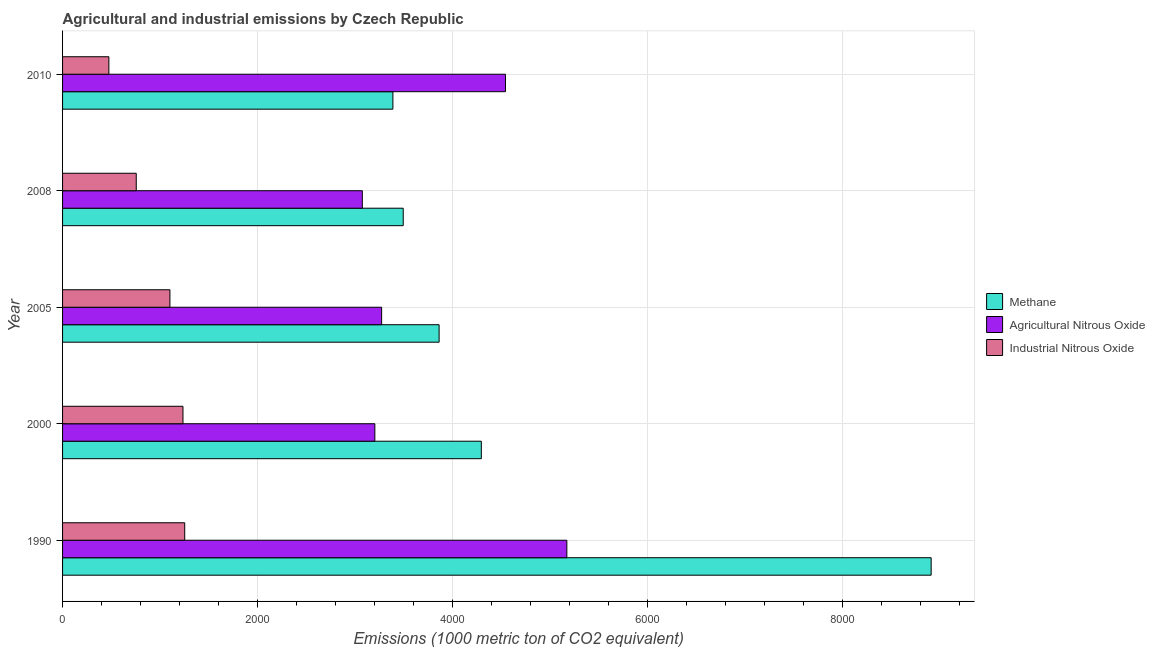How many groups of bars are there?
Your answer should be compact. 5. Are the number of bars per tick equal to the number of legend labels?
Ensure brevity in your answer.  Yes. Are the number of bars on each tick of the Y-axis equal?
Your response must be concise. Yes. How many bars are there on the 3rd tick from the bottom?
Keep it short and to the point. 3. What is the label of the 3rd group of bars from the top?
Your answer should be very brief. 2005. In how many cases, is the number of bars for a given year not equal to the number of legend labels?
Your response must be concise. 0. What is the amount of industrial nitrous oxide emissions in 1990?
Your answer should be compact. 1253.3. Across all years, what is the maximum amount of methane emissions?
Your response must be concise. 8912. Across all years, what is the minimum amount of agricultural nitrous oxide emissions?
Your response must be concise. 3075.6. In which year was the amount of industrial nitrous oxide emissions minimum?
Offer a very short reply. 2010. What is the total amount of methane emissions in the graph?
Your response must be concise. 2.40e+04. What is the difference between the amount of industrial nitrous oxide emissions in 2000 and that in 2005?
Ensure brevity in your answer.  133.9. What is the difference between the amount of industrial nitrous oxide emissions in 2000 and the amount of agricultural nitrous oxide emissions in 2008?
Offer a very short reply. -1840.2. What is the average amount of industrial nitrous oxide emissions per year?
Give a very brief answer. 964.28. In the year 2000, what is the difference between the amount of industrial nitrous oxide emissions and amount of methane emissions?
Provide a succinct answer. -3061.3. What is the ratio of the amount of industrial nitrous oxide emissions in 2005 to that in 2008?
Make the answer very short. 1.46. Is the difference between the amount of agricultural nitrous oxide emissions in 1990 and 2000 greater than the difference between the amount of industrial nitrous oxide emissions in 1990 and 2000?
Your answer should be compact. Yes. What is the difference between the highest and the second highest amount of methane emissions?
Make the answer very short. 4615.3. What is the difference between the highest and the lowest amount of agricultural nitrous oxide emissions?
Your answer should be compact. 2098.5. What does the 2nd bar from the top in 2008 represents?
Offer a very short reply. Agricultural Nitrous Oxide. What does the 1st bar from the bottom in 2000 represents?
Keep it short and to the point. Methane. Is it the case that in every year, the sum of the amount of methane emissions and amount of agricultural nitrous oxide emissions is greater than the amount of industrial nitrous oxide emissions?
Offer a very short reply. Yes. How many bars are there?
Offer a terse response. 15. What is the difference between two consecutive major ticks on the X-axis?
Ensure brevity in your answer.  2000. Are the values on the major ticks of X-axis written in scientific E-notation?
Give a very brief answer. No. Does the graph contain any zero values?
Offer a terse response. No. Does the graph contain grids?
Your response must be concise. Yes. How are the legend labels stacked?
Your answer should be compact. Vertical. What is the title of the graph?
Your response must be concise. Agricultural and industrial emissions by Czech Republic. Does "Taxes" appear as one of the legend labels in the graph?
Give a very brief answer. No. What is the label or title of the X-axis?
Provide a succinct answer. Emissions (1000 metric ton of CO2 equivalent). What is the label or title of the Y-axis?
Ensure brevity in your answer.  Year. What is the Emissions (1000 metric ton of CO2 equivalent) in Methane in 1990?
Your response must be concise. 8912. What is the Emissions (1000 metric ton of CO2 equivalent) in Agricultural Nitrous Oxide in 1990?
Offer a terse response. 5174.1. What is the Emissions (1000 metric ton of CO2 equivalent) in Industrial Nitrous Oxide in 1990?
Ensure brevity in your answer.  1253.3. What is the Emissions (1000 metric ton of CO2 equivalent) in Methane in 2000?
Offer a terse response. 4296.7. What is the Emissions (1000 metric ton of CO2 equivalent) of Agricultural Nitrous Oxide in 2000?
Offer a very short reply. 3204.1. What is the Emissions (1000 metric ton of CO2 equivalent) of Industrial Nitrous Oxide in 2000?
Your answer should be compact. 1235.4. What is the Emissions (1000 metric ton of CO2 equivalent) in Methane in 2005?
Provide a succinct answer. 3863.4. What is the Emissions (1000 metric ton of CO2 equivalent) in Agricultural Nitrous Oxide in 2005?
Make the answer very short. 3273.7. What is the Emissions (1000 metric ton of CO2 equivalent) of Industrial Nitrous Oxide in 2005?
Ensure brevity in your answer.  1101.5. What is the Emissions (1000 metric ton of CO2 equivalent) of Methane in 2008?
Your answer should be compact. 3495.2. What is the Emissions (1000 metric ton of CO2 equivalent) in Agricultural Nitrous Oxide in 2008?
Your response must be concise. 3075.6. What is the Emissions (1000 metric ton of CO2 equivalent) in Industrial Nitrous Oxide in 2008?
Your response must be concise. 756. What is the Emissions (1000 metric ton of CO2 equivalent) in Methane in 2010?
Your answer should be very brief. 3389.3. What is the Emissions (1000 metric ton of CO2 equivalent) of Agricultural Nitrous Oxide in 2010?
Provide a succinct answer. 4544.3. What is the Emissions (1000 metric ton of CO2 equivalent) of Industrial Nitrous Oxide in 2010?
Offer a terse response. 475.2. Across all years, what is the maximum Emissions (1000 metric ton of CO2 equivalent) of Methane?
Offer a very short reply. 8912. Across all years, what is the maximum Emissions (1000 metric ton of CO2 equivalent) of Agricultural Nitrous Oxide?
Ensure brevity in your answer.  5174.1. Across all years, what is the maximum Emissions (1000 metric ton of CO2 equivalent) in Industrial Nitrous Oxide?
Keep it short and to the point. 1253.3. Across all years, what is the minimum Emissions (1000 metric ton of CO2 equivalent) in Methane?
Your answer should be compact. 3389.3. Across all years, what is the minimum Emissions (1000 metric ton of CO2 equivalent) of Agricultural Nitrous Oxide?
Your answer should be very brief. 3075.6. Across all years, what is the minimum Emissions (1000 metric ton of CO2 equivalent) of Industrial Nitrous Oxide?
Your answer should be very brief. 475.2. What is the total Emissions (1000 metric ton of CO2 equivalent) of Methane in the graph?
Provide a succinct answer. 2.40e+04. What is the total Emissions (1000 metric ton of CO2 equivalent) in Agricultural Nitrous Oxide in the graph?
Keep it short and to the point. 1.93e+04. What is the total Emissions (1000 metric ton of CO2 equivalent) of Industrial Nitrous Oxide in the graph?
Ensure brevity in your answer.  4821.4. What is the difference between the Emissions (1000 metric ton of CO2 equivalent) in Methane in 1990 and that in 2000?
Provide a succinct answer. 4615.3. What is the difference between the Emissions (1000 metric ton of CO2 equivalent) in Agricultural Nitrous Oxide in 1990 and that in 2000?
Your answer should be compact. 1970. What is the difference between the Emissions (1000 metric ton of CO2 equivalent) of Industrial Nitrous Oxide in 1990 and that in 2000?
Ensure brevity in your answer.  17.9. What is the difference between the Emissions (1000 metric ton of CO2 equivalent) of Methane in 1990 and that in 2005?
Your response must be concise. 5048.6. What is the difference between the Emissions (1000 metric ton of CO2 equivalent) of Agricultural Nitrous Oxide in 1990 and that in 2005?
Keep it short and to the point. 1900.4. What is the difference between the Emissions (1000 metric ton of CO2 equivalent) of Industrial Nitrous Oxide in 1990 and that in 2005?
Give a very brief answer. 151.8. What is the difference between the Emissions (1000 metric ton of CO2 equivalent) in Methane in 1990 and that in 2008?
Make the answer very short. 5416.8. What is the difference between the Emissions (1000 metric ton of CO2 equivalent) in Agricultural Nitrous Oxide in 1990 and that in 2008?
Your answer should be compact. 2098.5. What is the difference between the Emissions (1000 metric ton of CO2 equivalent) in Industrial Nitrous Oxide in 1990 and that in 2008?
Offer a terse response. 497.3. What is the difference between the Emissions (1000 metric ton of CO2 equivalent) of Methane in 1990 and that in 2010?
Your response must be concise. 5522.7. What is the difference between the Emissions (1000 metric ton of CO2 equivalent) of Agricultural Nitrous Oxide in 1990 and that in 2010?
Make the answer very short. 629.8. What is the difference between the Emissions (1000 metric ton of CO2 equivalent) of Industrial Nitrous Oxide in 1990 and that in 2010?
Your response must be concise. 778.1. What is the difference between the Emissions (1000 metric ton of CO2 equivalent) in Methane in 2000 and that in 2005?
Your answer should be compact. 433.3. What is the difference between the Emissions (1000 metric ton of CO2 equivalent) of Agricultural Nitrous Oxide in 2000 and that in 2005?
Your response must be concise. -69.6. What is the difference between the Emissions (1000 metric ton of CO2 equivalent) in Industrial Nitrous Oxide in 2000 and that in 2005?
Provide a succinct answer. 133.9. What is the difference between the Emissions (1000 metric ton of CO2 equivalent) of Methane in 2000 and that in 2008?
Your response must be concise. 801.5. What is the difference between the Emissions (1000 metric ton of CO2 equivalent) of Agricultural Nitrous Oxide in 2000 and that in 2008?
Offer a terse response. 128.5. What is the difference between the Emissions (1000 metric ton of CO2 equivalent) of Industrial Nitrous Oxide in 2000 and that in 2008?
Give a very brief answer. 479.4. What is the difference between the Emissions (1000 metric ton of CO2 equivalent) in Methane in 2000 and that in 2010?
Ensure brevity in your answer.  907.4. What is the difference between the Emissions (1000 metric ton of CO2 equivalent) of Agricultural Nitrous Oxide in 2000 and that in 2010?
Provide a short and direct response. -1340.2. What is the difference between the Emissions (1000 metric ton of CO2 equivalent) of Industrial Nitrous Oxide in 2000 and that in 2010?
Your answer should be compact. 760.2. What is the difference between the Emissions (1000 metric ton of CO2 equivalent) in Methane in 2005 and that in 2008?
Ensure brevity in your answer.  368.2. What is the difference between the Emissions (1000 metric ton of CO2 equivalent) in Agricultural Nitrous Oxide in 2005 and that in 2008?
Your answer should be compact. 198.1. What is the difference between the Emissions (1000 metric ton of CO2 equivalent) in Industrial Nitrous Oxide in 2005 and that in 2008?
Offer a very short reply. 345.5. What is the difference between the Emissions (1000 metric ton of CO2 equivalent) in Methane in 2005 and that in 2010?
Make the answer very short. 474.1. What is the difference between the Emissions (1000 metric ton of CO2 equivalent) of Agricultural Nitrous Oxide in 2005 and that in 2010?
Ensure brevity in your answer.  -1270.6. What is the difference between the Emissions (1000 metric ton of CO2 equivalent) in Industrial Nitrous Oxide in 2005 and that in 2010?
Ensure brevity in your answer.  626.3. What is the difference between the Emissions (1000 metric ton of CO2 equivalent) of Methane in 2008 and that in 2010?
Make the answer very short. 105.9. What is the difference between the Emissions (1000 metric ton of CO2 equivalent) of Agricultural Nitrous Oxide in 2008 and that in 2010?
Make the answer very short. -1468.7. What is the difference between the Emissions (1000 metric ton of CO2 equivalent) in Industrial Nitrous Oxide in 2008 and that in 2010?
Provide a short and direct response. 280.8. What is the difference between the Emissions (1000 metric ton of CO2 equivalent) in Methane in 1990 and the Emissions (1000 metric ton of CO2 equivalent) in Agricultural Nitrous Oxide in 2000?
Your response must be concise. 5707.9. What is the difference between the Emissions (1000 metric ton of CO2 equivalent) of Methane in 1990 and the Emissions (1000 metric ton of CO2 equivalent) of Industrial Nitrous Oxide in 2000?
Give a very brief answer. 7676.6. What is the difference between the Emissions (1000 metric ton of CO2 equivalent) of Agricultural Nitrous Oxide in 1990 and the Emissions (1000 metric ton of CO2 equivalent) of Industrial Nitrous Oxide in 2000?
Your answer should be very brief. 3938.7. What is the difference between the Emissions (1000 metric ton of CO2 equivalent) in Methane in 1990 and the Emissions (1000 metric ton of CO2 equivalent) in Agricultural Nitrous Oxide in 2005?
Offer a terse response. 5638.3. What is the difference between the Emissions (1000 metric ton of CO2 equivalent) in Methane in 1990 and the Emissions (1000 metric ton of CO2 equivalent) in Industrial Nitrous Oxide in 2005?
Your response must be concise. 7810.5. What is the difference between the Emissions (1000 metric ton of CO2 equivalent) in Agricultural Nitrous Oxide in 1990 and the Emissions (1000 metric ton of CO2 equivalent) in Industrial Nitrous Oxide in 2005?
Your answer should be compact. 4072.6. What is the difference between the Emissions (1000 metric ton of CO2 equivalent) of Methane in 1990 and the Emissions (1000 metric ton of CO2 equivalent) of Agricultural Nitrous Oxide in 2008?
Offer a terse response. 5836.4. What is the difference between the Emissions (1000 metric ton of CO2 equivalent) in Methane in 1990 and the Emissions (1000 metric ton of CO2 equivalent) in Industrial Nitrous Oxide in 2008?
Keep it short and to the point. 8156. What is the difference between the Emissions (1000 metric ton of CO2 equivalent) in Agricultural Nitrous Oxide in 1990 and the Emissions (1000 metric ton of CO2 equivalent) in Industrial Nitrous Oxide in 2008?
Provide a short and direct response. 4418.1. What is the difference between the Emissions (1000 metric ton of CO2 equivalent) in Methane in 1990 and the Emissions (1000 metric ton of CO2 equivalent) in Agricultural Nitrous Oxide in 2010?
Your answer should be very brief. 4367.7. What is the difference between the Emissions (1000 metric ton of CO2 equivalent) in Methane in 1990 and the Emissions (1000 metric ton of CO2 equivalent) in Industrial Nitrous Oxide in 2010?
Keep it short and to the point. 8436.8. What is the difference between the Emissions (1000 metric ton of CO2 equivalent) of Agricultural Nitrous Oxide in 1990 and the Emissions (1000 metric ton of CO2 equivalent) of Industrial Nitrous Oxide in 2010?
Give a very brief answer. 4698.9. What is the difference between the Emissions (1000 metric ton of CO2 equivalent) of Methane in 2000 and the Emissions (1000 metric ton of CO2 equivalent) of Agricultural Nitrous Oxide in 2005?
Keep it short and to the point. 1023. What is the difference between the Emissions (1000 metric ton of CO2 equivalent) of Methane in 2000 and the Emissions (1000 metric ton of CO2 equivalent) of Industrial Nitrous Oxide in 2005?
Give a very brief answer. 3195.2. What is the difference between the Emissions (1000 metric ton of CO2 equivalent) in Agricultural Nitrous Oxide in 2000 and the Emissions (1000 metric ton of CO2 equivalent) in Industrial Nitrous Oxide in 2005?
Your answer should be very brief. 2102.6. What is the difference between the Emissions (1000 metric ton of CO2 equivalent) of Methane in 2000 and the Emissions (1000 metric ton of CO2 equivalent) of Agricultural Nitrous Oxide in 2008?
Offer a very short reply. 1221.1. What is the difference between the Emissions (1000 metric ton of CO2 equivalent) in Methane in 2000 and the Emissions (1000 metric ton of CO2 equivalent) in Industrial Nitrous Oxide in 2008?
Provide a succinct answer. 3540.7. What is the difference between the Emissions (1000 metric ton of CO2 equivalent) in Agricultural Nitrous Oxide in 2000 and the Emissions (1000 metric ton of CO2 equivalent) in Industrial Nitrous Oxide in 2008?
Offer a terse response. 2448.1. What is the difference between the Emissions (1000 metric ton of CO2 equivalent) of Methane in 2000 and the Emissions (1000 metric ton of CO2 equivalent) of Agricultural Nitrous Oxide in 2010?
Ensure brevity in your answer.  -247.6. What is the difference between the Emissions (1000 metric ton of CO2 equivalent) of Methane in 2000 and the Emissions (1000 metric ton of CO2 equivalent) of Industrial Nitrous Oxide in 2010?
Give a very brief answer. 3821.5. What is the difference between the Emissions (1000 metric ton of CO2 equivalent) in Agricultural Nitrous Oxide in 2000 and the Emissions (1000 metric ton of CO2 equivalent) in Industrial Nitrous Oxide in 2010?
Provide a succinct answer. 2728.9. What is the difference between the Emissions (1000 metric ton of CO2 equivalent) of Methane in 2005 and the Emissions (1000 metric ton of CO2 equivalent) of Agricultural Nitrous Oxide in 2008?
Provide a short and direct response. 787.8. What is the difference between the Emissions (1000 metric ton of CO2 equivalent) of Methane in 2005 and the Emissions (1000 metric ton of CO2 equivalent) of Industrial Nitrous Oxide in 2008?
Offer a terse response. 3107.4. What is the difference between the Emissions (1000 metric ton of CO2 equivalent) of Agricultural Nitrous Oxide in 2005 and the Emissions (1000 metric ton of CO2 equivalent) of Industrial Nitrous Oxide in 2008?
Your answer should be very brief. 2517.7. What is the difference between the Emissions (1000 metric ton of CO2 equivalent) of Methane in 2005 and the Emissions (1000 metric ton of CO2 equivalent) of Agricultural Nitrous Oxide in 2010?
Your answer should be very brief. -680.9. What is the difference between the Emissions (1000 metric ton of CO2 equivalent) in Methane in 2005 and the Emissions (1000 metric ton of CO2 equivalent) in Industrial Nitrous Oxide in 2010?
Give a very brief answer. 3388.2. What is the difference between the Emissions (1000 metric ton of CO2 equivalent) in Agricultural Nitrous Oxide in 2005 and the Emissions (1000 metric ton of CO2 equivalent) in Industrial Nitrous Oxide in 2010?
Your answer should be very brief. 2798.5. What is the difference between the Emissions (1000 metric ton of CO2 equivalent) of Methane in 2008 and the Emissions (1000 metric ton of CO2 equivalent) of Agricultural Nitrous Oxide in 2010?
Your answer should be compact. -1049.1. What is the difference between the Emissions (1000 metric ton of CO2 equivalent) in Methane in 2008 and the Emissions (1000 metric ton of CO2 equivalent) in Industrial Nitrous Oxide in 2010?
Provide a short and direct response. 3020. What is the difference between the Emissions (1000 metric ton of CO2 equivalent) of Agricultural Nitrous Oxide in 2008 and the Emissions (1000 metric ton of CO2 equivalent) of Industrial Nitrous Oxide in 2010?
Offer a very short reply. 2600.4. What is the average Emissions (1000 metric ton of CO2 equivalent) of Methane per year?
Keep it short and to the point. 4791.32. What is the average Emissions (1000 metric ton of CO2 equivalent) of Agricultural Nitrous Oxide per year?
Your answer should be compact. 3854.36. What is the average Emissions (1000 metric ton of CO2 equivalent) in Industrial Nitrous Oxide per year?
Ensure brevity in your answer.  964.28. In the year 1990, what is the difference between the Emissions (1000 metric ton of CO2 equivalent) of Methane and Emissions (1000 metric ton of CO2 equivalent) of Agricultural Nitrous Oxide?
Ensure brevity in your answer.  3737.9. In the year 1990, what is the difference between the Emissions (1000 metric ton of CO2 equivalent) in Methane and Emissions (1000 metric ton of CO2 equivalent) in Industrial Nitrous Oxide?
Give a very brief answer. 7658.7. In the year 1990, what is the difference between the Emissions (1000 metric ton of CO2 equivalent) of Agricultural Nitrous Oxide and Emissions (1000 metric ton of CO2 equivalent) of Industrial Nitrous Oxide?
Give a very brief answer. 3920.8. In the year 2000, what is the difference between the Emissions (1000 metric ton of CO2 equivalent) in Methane and Emissions (1000 metric ton of CO2 equivalent) in Agricultural Nitrous Oxide?
Make the answer very short. 1092.6. In the year 2000, what is the difference between the Emissions (1000 metric ton of CO2 equivalent) in Methane and Emissions (1000 metric ton of CO2 equivalent) in Industrial Nitrous Oxide?
Ensure brevity in your answer.  3061.3. In the year 2000, what is the difference between the Emissions (1000 metric ton of CO2 equivalent) in Agricultural Nitrous Oxide and Emissions (1000 metric ton of CO2 equivalent) in Industrial Nitrous Oxide?
Your response must be concise. 1968.7. In the year 2005, what is the difference between the Emissions (1000 metric ton of CO2 equivalent) of Methane and Emissions (1000 metric ton of CO2 equivalent) of Agricultural Nitrous Oxide?
Provide a short and direct response. 589.7. In the year 2005, what is the difference between the Emissions (1000 metric ton of CO2 equivalent) in Methane and Emissions (1000 metric ton of CO2 equivalent) in Industrial Nitrous Oxide?
Keep it short and to the point. 2761.9. In the year 2005, what is the difference between the Emissions (1000 metric ton of CO2 equivalent) of Agricultural Nitrous Oxide and Emissions (1000 metric ton of CO2 equivalent) of Industrial Nitrous Oxide?
Give a very brief answer. 2172.2. In the year 2008, what is the difference between the Emissions (1000 metric ton of CO2 equivalent) in Methane and Emissions (1000 metric ton of CO2 equivalent) in Agricultural Nitrous Oxide?
Your answer should be very brief. 419.6. In the year 2008, what is the difference between the Emissions (1000 metric ton of CO2 equivalent) of Methane and Emissions (1000 metric ton of CO2 equivalent) of Industrial Nitrous Oxide?
Offer a very short reply. 2739.2. In the year 2008, what is the difference between the Emissions (1000 metric ton of CO2 equivalent) in Agricultural Nitrous Oxide and Emissions (1000 metric ton of CO2 equivalent) in Industrial Nitrous Oxide?
Your answer should be compact. 2319.6. In the year 2010, what is the difference between the Emissions (1000 metric ton of CO2 equivalent) in Methane and Emissions (1000 metric ton of CO2 equivalent) in Agricultural Nitrous Oxide?
Your answer should be very brief. -1155. In the year 2010, what is the difference between the Emissions (1000 metric ton of CO2 equivalent) of Methane and Emissions (1000 metric ton of CO2 equivalent) of Industrial Nitrous Oxide?
Make the answer very short. 2914.1. In the year 2010, what is the difference between the Emissions (1000 metric ton of CO2 equivalent) of Agricultural Nitrous Oxide and Emissions (1000 metric ton of CO2 equivalent) of Industrial Nitrous Oxide?
Provide a succinct answer. 4069.1. What is the ratio of the Emissions (1000 metric ton of CO2 equivalent) in Methane in 1990 to that in 2000?
Give a very brief answer. 2.07. What is the ratio of the Emissions (1000 metric ton of CO2 equivalent) of Agricultural Nitrous Oxide in 1990 to that in 2000?
Offer a terse response. 1.61. What is the ratio of the Emissions (1000 metric ton of CO2 equivalent) of Industrial Nitrous Oxide in 1990 to that in 2000?
Make the answer very short. 1.01. What is the ratio of the Emissions (1000 metric ton of CO2 equivalent) of Methane in 1990 to that in 2005?
Your response must be concise. 2.31. What is the ratio of the Emissions (1000 metric ton of CO2 equivalent) of Agricultural Nitrous Oxide in 1990 to that in 2005?
Keep it short and to the point. 1.58. What is the ratio of the Emissions (1000 metric ton of CO2 equivalent) in Industrial Nitrous Oxide in 1990 to that in 2005?
Your answer should be very brief. 1.14. What is the ratio of the Emissions (1000 metric ton of CO2 equivalent) in Methane in 1990 to that in 2008?
Provide a succinct answer. 2.55. What is the ratio of the Emissions (1000 metric ton of CO2 equivalent) of Agricultural Nitrous Oxide in 1990 to that in 2008?
Your response must be concise. 1.68. What is the ratio of the Emissions (1000 metric ton of CO2 equivalent) in Industrial Nitrous Oxide in 1990 to that in 2008?
Your answer should be compact. 1.66. What is the ratio of the Emissions (1000 metric ton of CO2 equivalent) of Methane in 1990 to that in 2010?
Offer a very short reply. 2.63. What is the ratio of the Emissions (1000 metric ton of CO2 equivalent) in Agricultural Nitrous Oxide in 1990 to that in 2010?
Make the answer very short. 1.14. What is the ratio of the Emissions (1000 metric ton of CO2 equivalent) in Industrial Nitrous Oxide in 1990 to that in 2010?
Your answer should be very brief. 2.64. What is the ratio of the Emissions (1000 metric ton of CO2 equivalent) of Methane in 2000 to that in 2005?
Your response must be concise. 1.11. What is the ratio of the Emissions (1000 metric ton of CO2 equivalent) of Agricultural Nitrous Oxide in 2000 to that in 2005?
Provide a succinct answer. 0.98. What is the ratio of the Emissions (1000 metric ton of CO2 equivalent) of Industrial Nitrous Oxide in 2000 to that in 2005?
Provide a short and direct response. 1.12. What is the ratio of the Emissions (1000 metric ton of CO2 equivalent) of Methane in 2000 to that in 2008?
Make the answer very short. 1.23. What is the ratio of the Emissions (1000 metric ton of CO2 equivalent) in Agricultural Nitrous Oxide in 2000 to that in 2008?
Keep it short and to the point. 1.04. What is the ratio of the Emissions (1000 metric ton of CO2 equivalent) of Industrial Nitrous Oxide in 2000 to that in 2008?
Keep it short and to the point. 1.63. What is the ratio of the Emissions (1000 metric ton of CO2 equivalent) in Methane in 2000 to that in 2010?
Keep it short and to the point. 1.27. What is the ratio of the Emissions (1000 metric ton of CO2 equivalent) of Agricultural Nitrous Oxide in 2000 to that in 2010?
Keep it short and to the point. 0.71. What is the ratio of the Emissions (1000 metric ton of CO2 equivalent) of Industrial Nitrous Oxide in 2000 to that in 2010?
Your answer should be compact. 2.6. What is the ratio of the Emissions (1000 metric ton of CO2 equivalent) of Methane in 2005 to that in 2008?
Offer a very short reply. 1.11. What is the ratio of the Emissions (1000 metric ton of CO2 equivalent) of Agricultural Nitrous Oxide in 2005 to that in 2008?
Make the answer very short. 1.06. What is the ratio of the Emissions (1000 metric ton of CO2 equivalent) of Industrial Nitrous Oxide in 2005 to that in 2008?
Provide a succinct answer. 1.46. What is the ratio of the Emissions (1000 metric ton of CO2 equivalent) of Methane in 2005 to that in 2010?
Your response must be concise. 1.14. What is the ratio of the Emissions (1000 metric ton of CO2 equivalent) in Agricultural Nitrous Oxide in 2005 to that in 2010?
Give a very brief answer. 0.72. What is the ratio of the Emissions (1000 metric ton of CO2 equivalent) in Industrial Nitrous Oxide in 2005 to that in 2010?
Your answer should be very brief. 2.32. What is the ratio of the Emissions (1000 metric ton of CO2 equivalent) in Methane in 2008 to that in 2010?
Give a very brief answer. 1.03. What is the ratio of the Emissions (1000 metric ton of CO2 equivalent) of Agricultural Nitrous Oxide in 2008 to that in 2010?
Provide a short and direct response. 0.68. What is the ratio of the Emissions (1000 metric ton of CO2 equivalent) in Industrial Nitrous Oxide in 2008 to that in 2010?
Offer a terse response. 1.59. What is the difference between the highest and the second highest Emissions (1000 metric ton of CO2 equivalent) in Methane?
Your answer should be very brief. 4615.3. What is the difference between the highest and the second highest Emissions (1000 metric ton of CO2 equivalent) of Agricultural Nitrous Oxide?
Give a very brief answer. 629.8. What is the difference between the highest and the lowest Emissions (1000 metric ton of CO2 equivalent) in Methane?
Provide a succinct answer. 5522.7. What is the difference between the highest and the lowest Emissions (1000 metric ton of CO2 equivalent) in Agricultural Nitrous Oxide?
Make the answer very short. 2098.5. What is the difference between the highest and the lowest Emissions (1000 metric ton of CO2 equivalent) of Industrial Nitrous Oxide?
Keep it short and to the point. 778.1. 